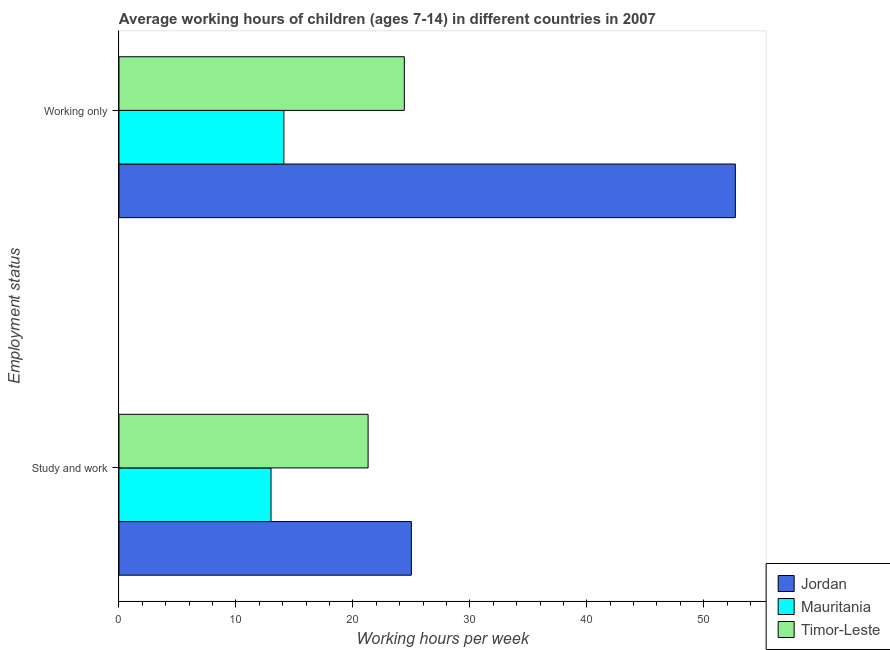How many different coloured bars are there?
Offer a very short reply. 3. How many groups of bars are there?
Provide a short and direct response. 2. Are the number of bars on each tick of the Y-axis equal?
Offer a very short reply. Yes. How many bars are there on the 2nd tick from the top?
Your response must be concise. 3. How many bars are there on the 2nd tick from the bottom?
Provide a short and direct response. 3. What is the label of the 2nd group of bars from the top?
Your answer should be compact. Study and work. What is the average working hour of children involved in study and work in Timor-Leste?
Provide a short and direct response. 21.3. Across all countries, what is the maximum average working hour of children involved in only work?
Keep it short and to the point. 52.7. Across all countries, what is the minimum average working hour of children involved in only work?
Keep it short and to the point. 14.1. In which country was the average working hour of children involved in only work maximum?
Keep it short and to the point. Jordan. In which country was the average working hour of children involved in study and work minimum?
Your answer should be very brief. Mauritania. What is the total average working hour of children involved in only work in the graph?
Provide a short and direct response. 91.2. What is the difference between the average working hour of children involved in only work in Jordan and that in Timor-Leste?
Provide a short and direct response. 28.3. What is the difference between the average working hour of children involved in study and work in Jordan and the average working hour of children involved in only work in Mauritania?
Make the answer very short. 10.9. What is the average average working hour of children involved in only work per country?
Keep it short and to the point. 30.4. What is the difference between the average working hour of children involved in study and work and average working hour of children involved in only work in Jordan?
Make the answer very short. -27.7. What is the ratio of the average working hour of children involved in only work in Mauritania to that in Jordan?
Provide a short and direct response. 0.27. Is the average working hour of children involved in study and work in Timor-Leste less than that in Mauritania?
Provide a short and direct response. No. What does the 2nd bar from the top in Study and work represents?
Ensure brevity in your answer.  Mauritania. What does the 1st bar from the bottom in Study and work represents?
Your answer should be compact. Jordan. What is the difference between two consecutive major ticks on the X-axis?
Offer a terse response. 10. How many legend labels are there?
Provide a short and direct response. 3. How are the legend labels stacked?
Your answer should be very brief. Vertical. What is the title of the graph?
Give a very brief answer. Average working hours of children (ages 7-14) in different countries in 2007. What is the label or title of the X-axis?
Keep it short and to the point. Working hours per week. What is the label or title of the Y-axis?
Your answer should be compact. Employment status. What is the Working hours per week of Timor-Leste in Study and work?
Keep it short and to the point. 21.3. What is the Working hours per week in Jordan in Working only?
Your answer should be very brief. 52.7. What is the Working hours per week of Mauritania in Working only?
Make the answer very short. 14.1. What is the Working hours per week in Timor-Leste in Working only?
Make the answer very short. 24.4. Across all Employment status, what is the maximum Working hours per week in Jordan?
Provide a succinct answer. 52.7. Across all Employment status, what is the maximum Working hours per week of Timor-Leste?
Your response must be concise. 24.4. Across all Employment status, what is the minimum Working hours per week in Jordan?
Offer a terse response. 25. Across all Employment status, what is the minimum Working hours per week in Mauritania?
Offer a terse response. 13. Across all Employment status, what is the minimum Working hours per week of Timor-Leste?
Offer a terse response. 21.3. What is the total Working hours per week of Jordan in the graph?
Your answer should be compact. 77.7. What is the total Working hours per week in Mauritania in the graph?
Make the answer very short. 27.1. What is the total Working hours per week in Timor-Leste in the graph?
Your response must be concise. 45.7. What is the difference between the Working hours per week of Jordan in Study and work and that in Working only?
Offer a terse response. -27.7. What is the difference between the Working hours per week of Jordan in Study and work and the Working hours per week of Timor-Leste in Working only?
Ensure brevity in your answer.  0.6. What is the difference between the Working hours per week of Mauritania in Study and work and the Working hours per week of Timor-Leste in Working only?
Keep it short and to the point. -11.4. What is the average Working hours per week of Jordan per Employment status?
Your answer should be very brief. 38.85. What is the average Working hours per week of Mauritania per Employment status?
Your response must be concise. 13.55. What is the average Working hours per week in Timor-Leste per Employment status?
Ensure brevity in your answer.  22.85. What is the difference between the Working hours per week in Jordan and Working hours per week in Timor-Leste in Study and work?
Ensure brevity in your answer.  3.7. What is the difference between the Working hours per week in Mauritania and Working hours per week in Timor-Leste in Study and work?
Your answer should be very brief. -8.3. What is the difference between the Working hours per week of Jordan and Working hours per week of Mauritania in Working only?
Provide a short and direct response. 38.6. What is the difference between the Working hours per week of Jordan and Working hours per week of Timor-Leste in Working only?
Offer a terse response. 28.3. What is the difference between the Working hours per week in Mauritania and Working hours per week in Timor-Leste in Working only?
Provide a succinct answer. -10.3. What is the ratio of the Working hours per week in Jordan in Study and work to that in Working only?
Offer a terse response. 0.47. What is the ratio of the Working hours per week in Mauritania in Study and work to that in Working only?
Your answer should be compact. 0.92. What is the ratio of the Working hours per week of Timor-Leste in Study and work to that in Working only?
Make the answer very short. 0.87. What is the difference between the highest and the second highest Working hours per week in Jordan?
Offer a very short reply. 27.7. What is the difference between the highest and the second highest Working hours per week of Timor-Leste?
Provide a short and direct response. 3.1. What is the difference between the highest and the lowest Working hours per week of Jordan?
Make the answer very short. 27.7. What is the difference between the highest and the lowest Working hours per week of Mauritania?
Provide a succinct answer. 1.1. What is the difference between the highest and the lowest Working hours per week of Timor-Leste?
Offer a terse response. 3.1. 